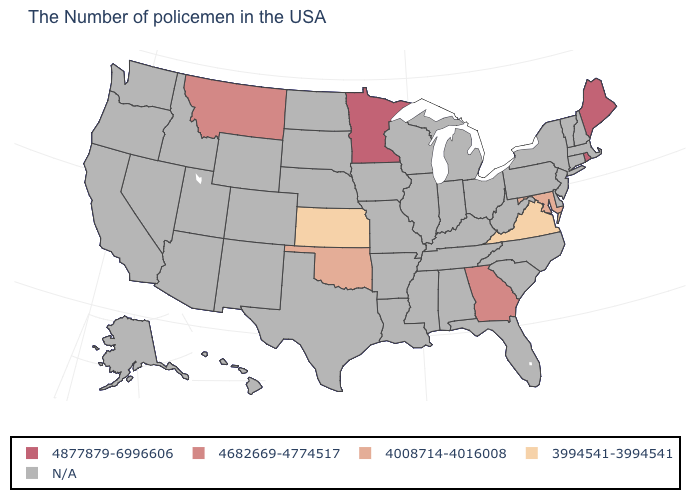Which states have the lowest value in the USA?
Be succinct. Virginia, Kansas. What is the value of Delaware?
Concise answer only. N/A. Is the legend a continuous bar?
Quick response, please. No. What is the value of New York?
Concise answer only. N/A. Name the states that have a value in the range N/A?
Concise answer only. Massachusetts, New Hampshire, Vermont, Connecticut, New York, New Jersey, Delaware, Pennsylvania, North Carolina, South Carolina, West Virginia, Ohio, Florida, Michigan, Kentucky, Indiana, Alabama, Tennessee, Wisconsin, Illinois, Mississippi, Louisiana, Missouri, Arkansas, Iowa, Nebraska, Texas, South Dakota, North Dakota, Wyoming, Colorado, New Mexico, Utah, Arizona, Idaho, Nevada, California, Washington, Oregon, Alaska, Hawaii. Which states have the lowest value in the USA?
Be succinct. Virginia, Kansas. What is the value of Florida?
Give a very brief answer. N/A. What is the lowest value in the USA?
Keep it brief. 3994541-3994541. Name the states that have a value in the range N/A?
Write a very short answer. Massachusetts, New Hampshire, Vermont, Connecticut, New York, New Jersey, Delaware, Pennsylvania, North Carolina, South Carolina, West Virginia, Ohio, Florida, Michigan, Kentucky, Indiana, Alabama, Tennessee, Wisconsin, Illinois, Mississippi, Louisiana, Missouri, Arkansas, Iowa, Nebraska, Texas, South Dakota, North Dakota, Wyoming, Colorado, New Mexico, Utah, Arizona, Idaho, Nevada, California, Washington, Oregon, Alaska, Hawaii. Does Kansas have the lowest value in the USA?
Concise answer only. Yes. 